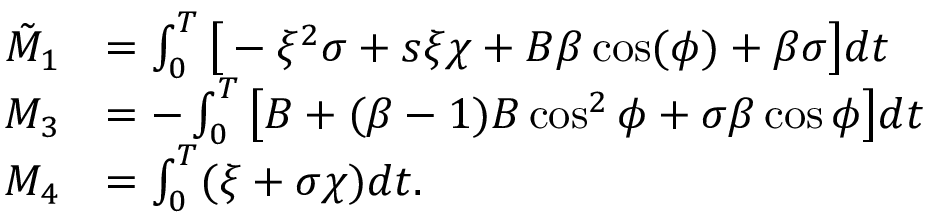Convert formula to latex. <formula><loc_0><loc_0><loc_500><loc_500>\begin{array} { r l } { \tilde { M } _ { 1 } } & { = \int _ { 0 } ^ { T } \left [ - \xi ^ { 2 } \sigma + s \xi \chi + B \beta \cos ( \phi ) + \beta \sigma \right ] d t } \\ { M _ { 3 } } & { = - \int _ { 0 } ^ { T } \left [ B + ( \beta - 1 ) B \cos ^ { 2 } \phi + \sigma \beta \cos \phi \right ] d t } \\ { M _ { 4 } } & { = \int _ { 0 } ^ { T } ( \xi + \sigma \chi ) d t . } \end{array}</formula> 